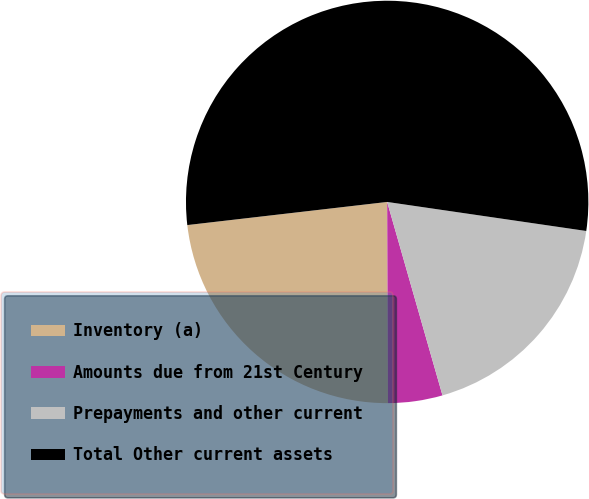Convert chart. <chart><loc_0><loc_0><loc_500><loc_500><pie_chart><fcel>Inventory (a)<fcel>Amounts due from 21st Century<fcel>Prepayments and other current<fcel>Total Other current assets<nl><fcel>23.23%<fcel>4.37%<fcel>18.26%<fcel>54.14%<nl></chart> 